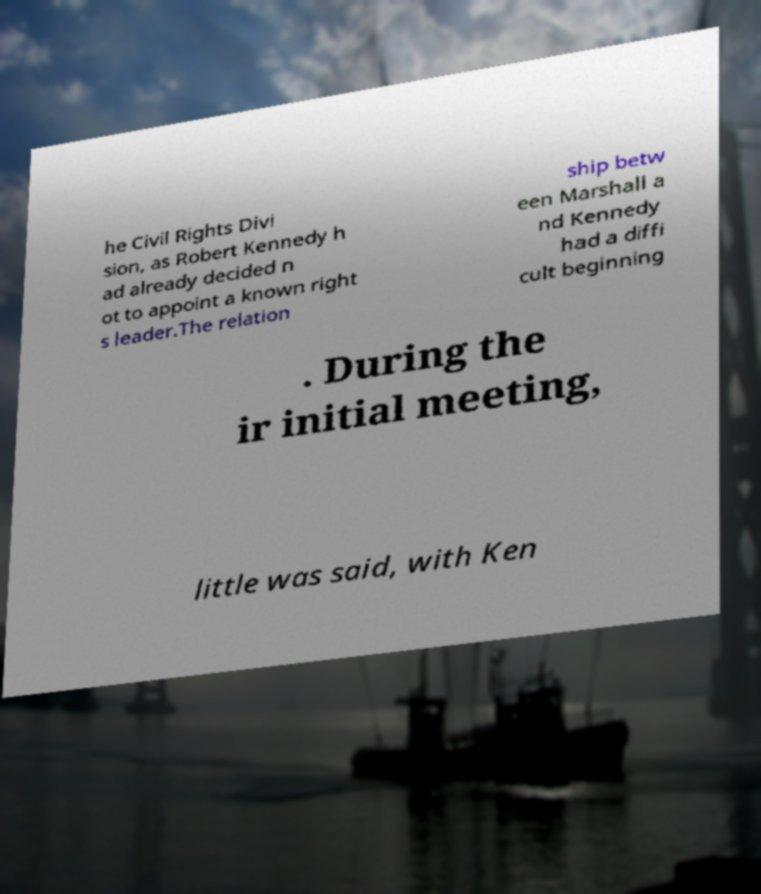Could you assist in decoding the text presented in this image and type it out clearly? he Civil Rights Divi sion, as Robert Kennedy h ad already decided n ot to appoint a known right s leader.The relation ship betw een Marshall a nd Kennedy had a diffi cult beginning . During the ir initial meeting, little was said, with Ken 